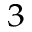<formula> <loc_0><loc_0><loc_500><loc_500>^ { 3 }</formula> 